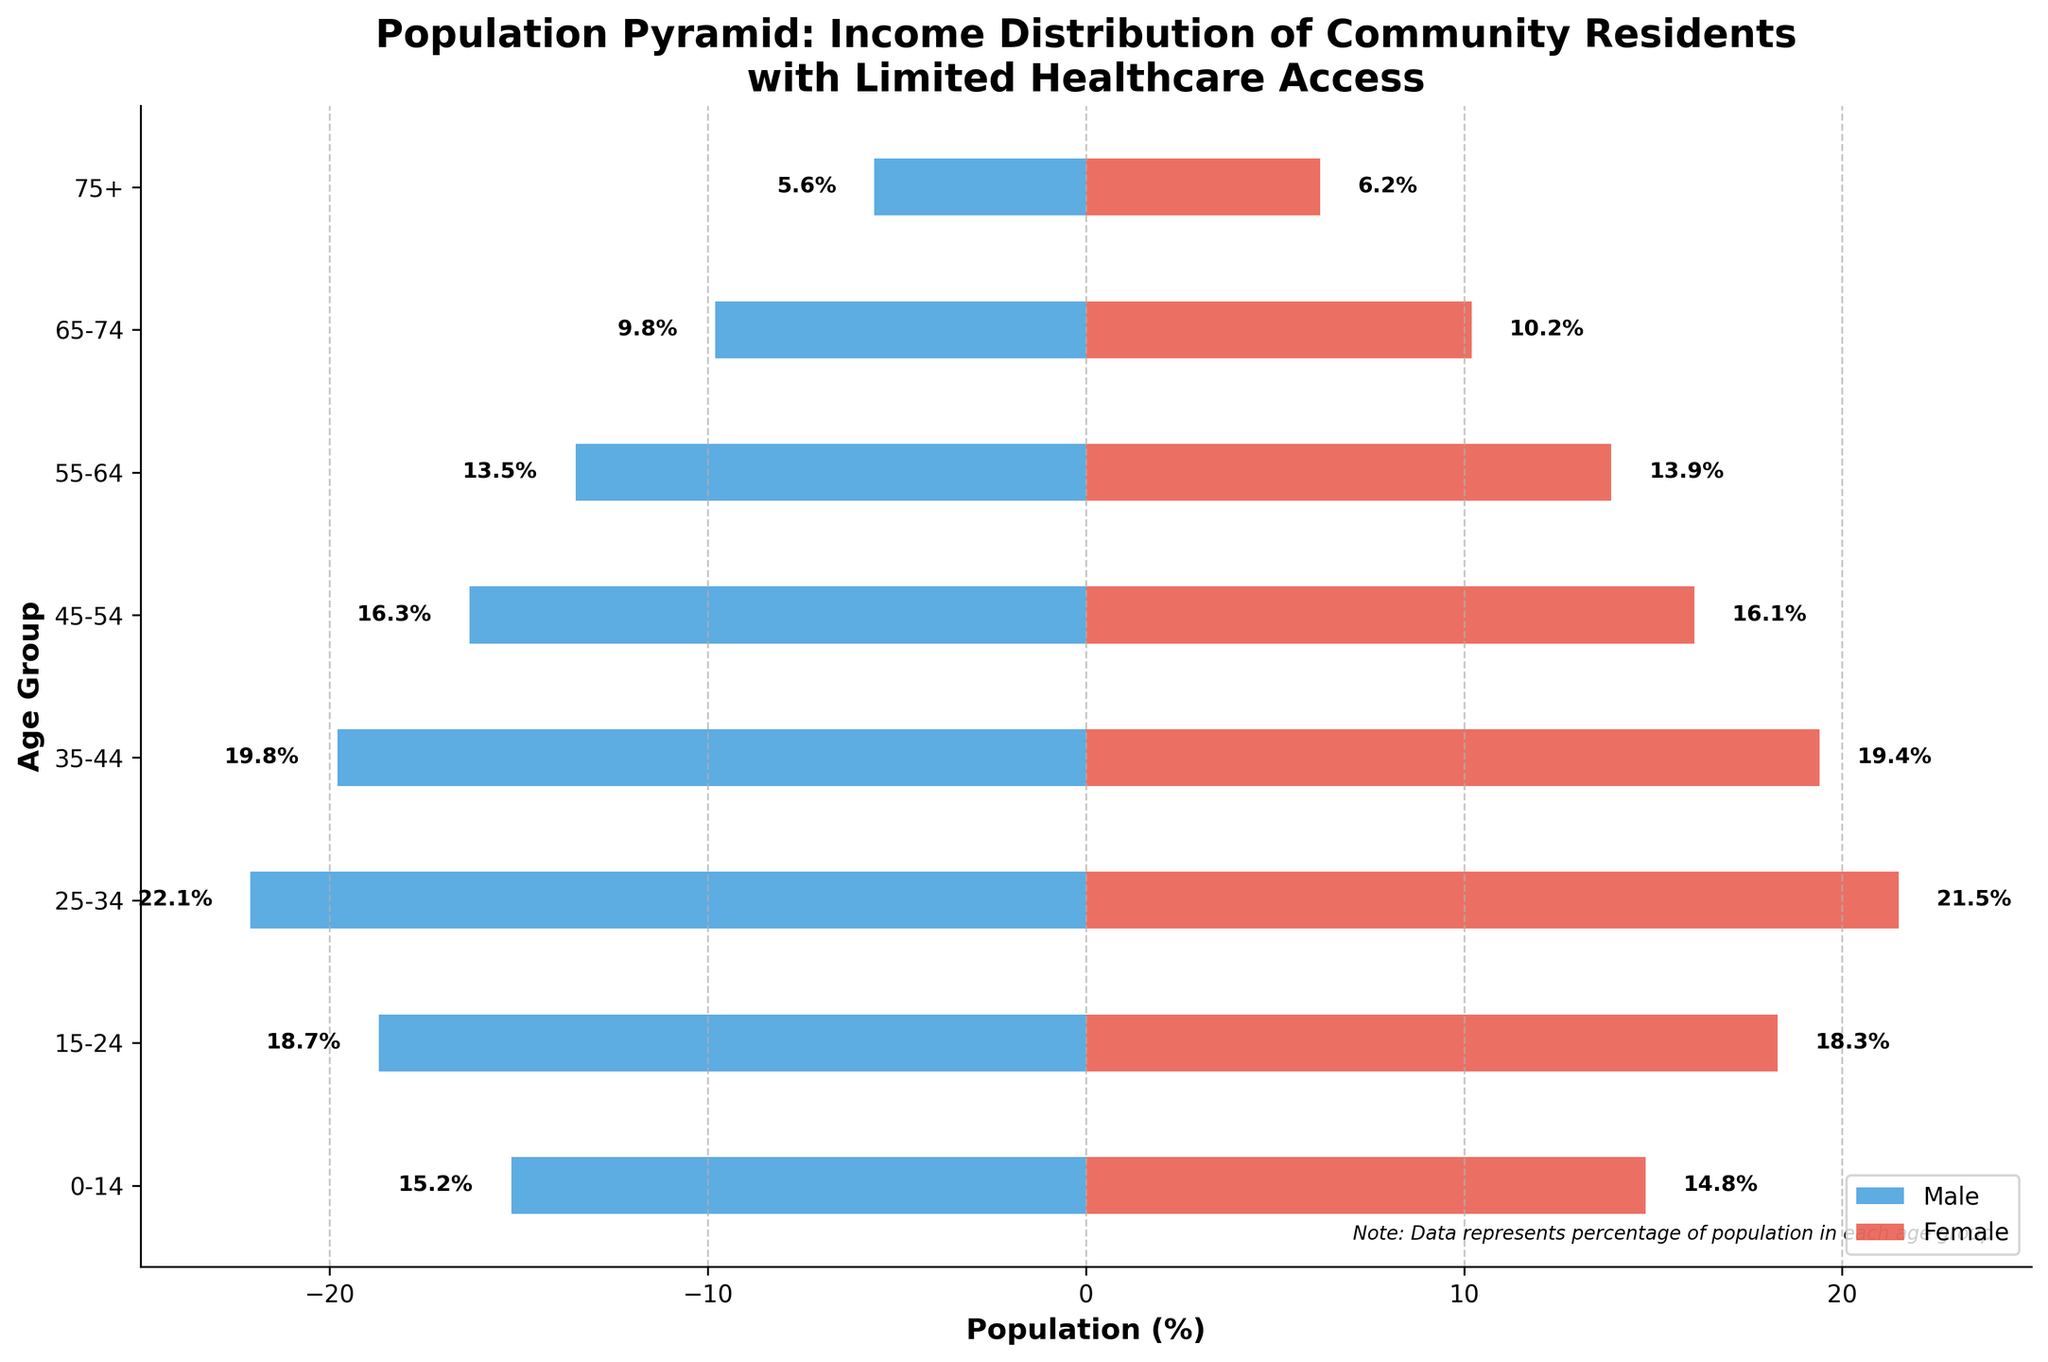what is the title of the chart? The title can be found at the top of the chart and provides the context of the data being presented. Here, it reads "Population Pyramid: Income Distribution of Community Residents with Limited Healthcare Access".
Answer: Population Pyramid: Income Distribution of Community Residents with Limited Healthcare Access What is the largest male age group by percentage? To answer this, look at the longest bar for the male side of the pyramid. The largest value for males is -22.1% in the 25-34 age group.
Answer: 25-34 How does the percentage of females aged 75+ compare to males in the same age group? Compare the lengths of the two bars for the 75+ age group. Females in the 75+ age group have a percentage of 6.2%, while males have -5.6%.
Answer: Females aged 75+ have a higher percentage What is the combined percentage of males and females in the 35-44 age group? Sum the absolute value of the percentage for males and females in the 35-44 age group. Male is 19.8% and female is 19.4%. Combined, the percentage is 19.8% + 19.4% = 39.2%.
Answer: 39.2% Which age group has the closest percentage between males and females? Look for the age group where the male and female bars are closest in length. The 45-54 age group has -16.3% for males and 16.1% for females, which are very close.
Answer: 45-54 Is the female percentage higher than the male percentage in the 0-14 age group? Compare the lengths of the bars in the 0-14 age group. Females have 14.8% and males have -15.2%.
Answer: No What is the average percentage of males in the 55-64 and 65-74 age groups? Add the percentages of males in these age groups and divide by the number of age groups. (-13.5% + -9.8%) / 2 = -11.65%.
Answer: 11.65% Does any age group have a percentage above 20% for either gender? Check the bars for both genders in all age groups. The 25-34 age group has 22.1% males and 21.5% females.
Answer: Yes Which age group has the smallest female percentage? Locate the shortest bar for females. The smallest female percentage is in the 0-14 age group with 14.8%.
Answer: 0-14 